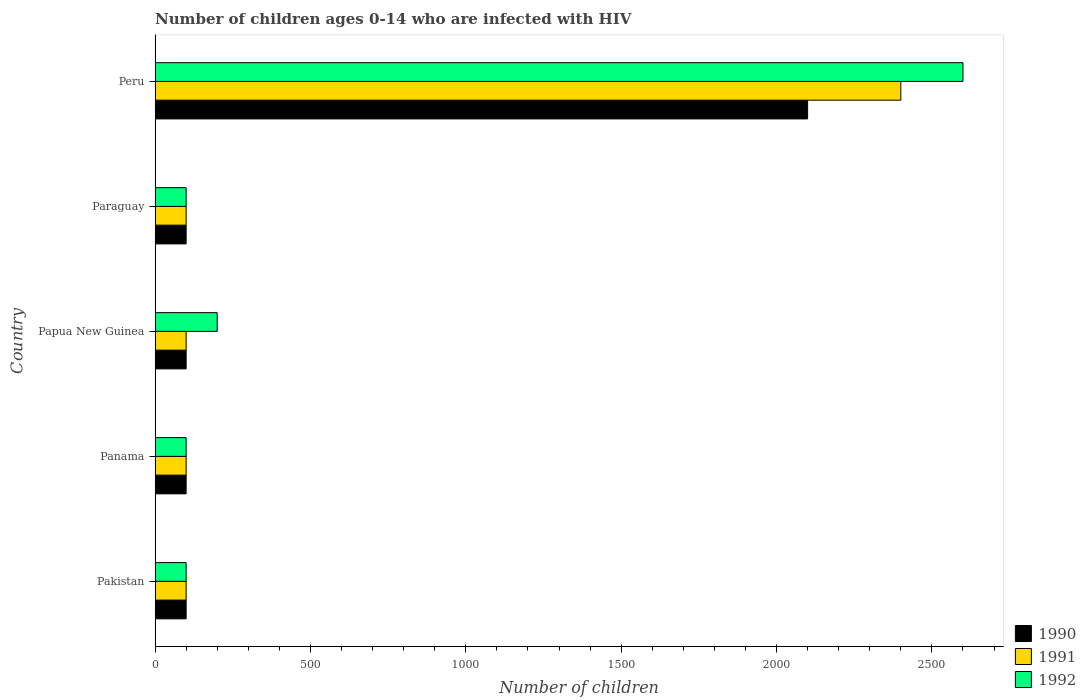How many different coloured bars are there?
Ensure brevity in your answer.  3. Are the number of bars per tick equal to the number of legend labels?
Provide a short and direct response. Yes. Are the number of bars on each tick of the Y-axis equal?
Keep it short and to the point. Yes. What is the label of the 4th group of bars from the top?
Keep it short and to the point. Panama. What is the number of HIV infected children in 1990 in Paraguay?
Keep it short and to the point. 100. Across all countries, what is the maximum number of HIV infected children in 1990?
Provide a short and direct response. 2100. Across all countries, what is the minimum number of HIV infected children in 1991?
Give a very brief answer. 100. In which country was the number of HIV infected children in 1992 minimum?
Ensure brevity in your answer.  Pakistan. What is the total number of HIV infected children in 1991 in the graph?
Your answer should be very brief. 2800. What is the difference between the number of HIV infected children in 1990 in Pakistan and that in Peru?
Provide a succinct answer. -2000. What is the difference between the number of HIV infected children in 1991 in Panama and the number of HIV infected children in 1990 in Papua New Guinea?
Provide a succinct answer. 0. What is the average number of HIV infected children in 1990 per country?
Your response must be concise. 500. What is the difference between the number of HIV infected children in 1992 and number of HIV infected children in 1990 in Papua New Guinea?
Provide a succinct answer. 100. What is the ratio of the number of HIV infected children in 1992 in Pakistan to that in Peru?
Make the answer very short. 0.04. Is the difference between the number of HIV infected children in 1992 in Paraguay and Peru greater than the difference between the number of HIV infected children in 1990 in Paraguay and Peru?
Offer a very short reply. No. What is the difference between the highest and the second highest number of HIV infected children in 1992?
Your answer should be compact. 2400. What is the difference between the highest and the lowest number of HIV infected children in 1990?
Offer a terse response. 2000. Is the sum of the number of HIV infected children in 1992 in Pakistan and Panama greater than the maximum number of HIV infected children in 1991 across all countries?
Offer a terse response. No. What does the 2nd bar from the bottom in Pakistan represents?
Your response must be concise. 1991. Does the graph contain any zero values?
Provide a succinct answer. No. Where does the legend appear in the graph?
Provide a short and direct response. Bottom right. How many legend labels are there?
Offer a terse response. 3. What is the title of the graph?
Ensure brevity in your answer.  Number of children ages 0-14 who are infected with HIV. What is the label or title of the X-axis?
Offer a very short reply. Number of children. What is the label or title of the Y-axis?
Ensure brevity in your answer.  Country. What is the Number of children in 1990 in Pakistan?
Offer a terse response. 100. What is the Number of children in 1992 in Panama?
Provide a succinct answer. 100. What is the Number of children in 1990 in Papua New Guinea?
Ensure brevity in your answer.  100. What is the Number of children in 1991 in Papua New Guinea?
Offer a very short reply. 100. What is the Number of children of 1990 in Paraguay?
Your answer should be very brief. 100. What is the Number of children of 1991 in Paraguay?
Your answer should be very brief. 100. What is the Number of children in 1990 in Peru?
Keep it short and to the point. 2100. What is the Number of children in 1991 in Peru?
Your answer should be compact. 2400. What is the Number of children of 1992 in Peru?
Give a very brief answer. 2600. Across all countries, what is the maximum Number of children of 1990?
Make the answer very short. 2100. Across all countries, what is the maximum Number of children in 1991?
Provide a short and direct response. 2400. Across all countries, what is the maximum Number of children of 1992?
Give a very brief answer. 2600. What is the total Number of children in 1990 in the graph?
Give a very brief answer. 2500. What is the total Number of children in 1991 in the graph?
Offer a terse response. 2800. What is the total Number of children of 1992 in the graph?
Provide a short and direct response. 3100. What is the difference between the Number of children of 1990 in Pakistan and that in Panama?
Your response must be concise. 0. What is the difference between the Number of children in 1991 in Pakistan and that in Panama?
Provide a short and direct response. 0. What is the difference between the Number of children of 1992 in Pakistan and that in Papua New Guinea?
Provide a succinct answer. -100. What is the difference between the Number of children of 1990 in Pakistan and that in Paraguay?
Offer a very short reply. 0. What is the difference between the Number of children in 1991 in Pakistan and that in Paraguay?
Provide a succinct answer. 0. What is the difference between the Number of children in 1990 in Pakistan and that in Peru?
Make the answer very short. -2000. What is the difference between the Number of children in 1991 in Pakistan and that in Peru?
Your answer should be very brief. -2300. What is the difference between the Number of children in 1992 in Pakistan and that in Peru?
Keep it short and to the point. -2500. What is the difference between the Number of children of 1990 in Panama and that in Papua New Guinea?
Your response must be concise. 0. What is the difference between the Number of children of 1992 in Panama and that in Papua New Guinea?
Provide a short and direct response. -100. What is the difference between the Number of children of 1990 in Panama and that in Paraguay?
Keep it short and to the point. 0. What is the difference between the Number of children in 1991 in Panama and that in Paraguay?
Provide a short and direct response. 0. What is the difference between the Number of children of 1990 in Panama and that in Peru?
Ensure brevity in your answer.  -2000. What is the difference between the Number of children of 1991 in Panama and that in Peru?
Keep it short and to the point. -2300. What is the difference between the Number of children of 1992 in Panama and that in Peru?
Provide a succinct answer. -2500. What is the difference between the Number of children in 1990 in Papua New Guinea and that in Paraguay?
Offer a terse response. 0. What is the difference between the Number of children in 1991 in Papua New Guinea and that in Paraguay?
Give a very brief answer. 0. What is the difference between the Number of children of 1990 in Papua New Guinea and that in Peru?
Your response must be concise. -2000. What is the difference between the Number of children in 1991 in Papua New Guinea and that in Peru?
Your response must be concise. -2300. What is the difference between the Number of children of 1992 in Papua New Guinea and that in Peru?
Offer a very short reply. -2400. What is the difference between the Number of children of 1990 in Paraguay and that in Peru?
Your response must be concise. -2000. What is the difference between the Number of children of 1991 in Paraguay and that in Peru?
Make the answer very short. -2300. What is the difference between the Number of children of 1992 in Paraguay and that in Peru?
Ensure brevity in your answer.  -2500. What is the difference between the Number of children of 1991 in Pakistan and the Number of children of 1992 in Panama?
Provide a succinct answer. 0. What is the difference between the Number of children in 1990 in Pakistan and the Number of children in 1992 in Papua New Guinea?
Ensure brevity in your answer.  -100. What is the difference between the Number of children in 1991 in Pakistan and the Number of children in 1992 in Papua New Guinea?
Offer a very short reply. -100. What is the difference between the Number of children of 1990 in Pakistan and the Number of children of 1991 in Paraguay?
Your answer should be very brief. 0. What is the difference between the Number of children of 1991 in Pakistan and the Number of children of 1992 in Paraguay?
Your answer should be very brief. 0. What is the difference between the Number of children of 1990 in Pakistan and the Number of children of 1991 in Peru?
Your response must be concise. -2300. What is the difference between the Number of children of 1990 in Pakistan and the Number of children of 1992 in Peru?
Your answer should be very brief. -2500. What is the difference between the Number of children of 1991 in Pakistan and the Number of children of 1992 in Peru?
Offer a very short reply. -2500. What is the difference between the Number of children of 1990 in Panama and the Number of children of 1992 in Papua New Guinea?
Provide a short and direct response. -100. What is the difference between the Number of children of 1991 in Panama and the Number of children of 1992 in Papua New Guinea?
Keep it short and to the point. -100. What is the difference between the Number of children of 1990 in Panama and the Number of children of 1991 in Paraguay?
Your answer should be very brief. 0. What is the difference between the Number of children of 1991 in Panama and the Number of children of 1992 in Paraguay?
Offer a very short reply. 0. What is the difference between the Number of children in 1990 in Panama and the Number of children in 1991 in Peru?
Give a very brief answer. -2300. What is the difference between the Number of children in 1990 in Panama and the Number of children in 1992 in Peru?
Provide a succinct answer. -2500. What is the difference between the Number of children in 1991 in Panama and the Number of children in 1992 in Peru?
Provide a succinct answer. -2500. What is the difference between the Number of children in 1990 in Papua New Guinea and the Number of children in 1991 in Paraguay?
Keep it short and to the point. 0. What is the difference between the Number of children of 1991 in Papua New Guinea and the Number of children of 1992 in Paraguay?
Your answer should be very brief. 0. What is the difference between the Number of children in 1990 in Papua New Guinea and the Number of children in 1991 in Peru?
Keep it short and to the point. -2300. What is the difference between the Number of children of 1990 in Papua New Guinea and the Number of children of 1992 in Peru?
Give a very brief answer. -2500. What is the difference between the Number of children of 1991 in Papua New Guinea and the Number of children of 1992 in Peru?
Make the answer very short. -2500. What is the difference between the Number of children in 1990 in Paraguay and the Number of children in 1991 in Peru?
Keep it short and to the point. -2300. What is the difference between the Number of children of 1990 in Paraguay and the Number of children of 1992 in Peru?
Offer a very short reply. -2500. What is the difference between the Number of children in 1991 in Paraguay and the Number of children in 1992 in Peru?
Give a very brief answer. -2500. What is the average Number of children of 1990 per country?
Your answer should be very brief. 500. What is the average Number of children of 1991 per country?
Provide a short and direct response. 560. What is the average Number of children of 1992 per country?
Give a very brief answer. 620. What is the difference between the Number of children in 1990 and Number of children in 1991 in Pakistan?
Your response must be concise. 0. What is the difference between the Number of children of 1990 and Number of children of 1992 in Pakistan?
Provide a short and direct response. 0. What is the difference between the Number of children in 1991 and Number of children in 1992 in Pakistan?
Make the answer very short. 0. What is the difference between the Number of children of 1991 and Number of children of 1992 in Panama?
Give a very brief answer. 0. What is the difference between the Number of children of 1990 and Number of children of 1991 in Papua New Guinea?
Keep it short and to the point. 0. What is the difference between the Number of children of 1990 and Number of children of 1992 in Papua New Guinea?
Keep it short and to the point. -100. What is the difference between the Number of children of 1991 and Number of children of 1992 in Papua New Guinea?
Your answer should be compact. -100. What is the difference between the Number of children of 1990 and Number of children of 1991 in Paraguay?
Offer a terse response. 0. What is the difference between the Number of children in 1990 and Number of children in 1991 in Peru?
Offer a very short reply. -300. What is the difference between the Number of children of 1990 and Number of children of 1992 in Peru?
Provide a short and direct response. -500. What is the difference between the Number of children of 1991 and Number of children of 1992 in Peru?
Your response must be concise. -200. What is the ratio of the Number of children in 1990 in Pakistan to that in Panama?
Keep it short and to the point. 1. What is the ratio of the Number of children of 1990 in Pakistan to that in Paraguay?
Keep it short and to the point. 1. What is the ratio of the Number of children of 1992 in Pakistan to that in Paraguay?
Keep it short and to the point. 1. What is the ratio of the Number of children of 1990 in Pakistan to that in Peru?
Your answer should be compact. 0.05. What is the ratio of the Number of children of 1991 in Pakistan to that in Peru?
Provide a succinct answer. 0.04. What is the ratio of the Number of children in 1992 in Pakistan to that in Peru?
Make the answer very short. 0.04. What is the ratio of the Number of children of 1990 in Panama to that in Papua New Guinea?
Offer a very short reply. 1. What is the ratio of the Number of children of 1992 in Panama to that in Papua New Guinea?
Offer a terse response. 0.5. What is the ratio of the Number of children in 1990 in Panama to that in Peru?
Your answer should be very brief. 0.05. What is the ratio of the Number of children in 1991 in Panama to that in Peru?
Offer a very short reply. 0.04. What is the ratio of the Number of children in 1992 in Panama to that in Peru?
Provide a short and direct response. 0.04. What is the ratio of the Number of children of 1991 in Papua New Guinea to that in Paraguay?
Your response must be concise. 1. What is the ratio of the Number of children of 1990 in Papua New Guinea to that in Peru?
Keep it short and to the point. 0.05. What is the ratio of the Number of children in 1991 in Papua New Guinea to that in Peru?
Ensure brevity in your answer.  0.04. What is the ratio of the Number of children of 1992 in Papua New Guinea to that in Peru?
Your answer should be very brief. 0.08. What is the ratio of the Number of children of 1990 in Paraguay to that in Peru?
Provide a succinct answer. 0.05. What is the ratio of the Number of children in 1991 in Paraguay to that in Peru?
Your answer should be compact. 0.04. What is the ratio of the Number of children of 1992 in Paraguay to that in Peru?
Give a very brief answer. 0.04. What is the difference between the highest and the second highest Number of children of 1990?
Give a very brief answer. 2000. What is the difference between the highest and the second highest Number of children in 1991?
Provide a short and direct response. 2300. What is the difference between the highest and the second highest Number of children in 1992?
Keep it short and to the point. 2400. What is the difference between the highest and the lowest Number of children in 1990?
Your answer should be compact. 2000. What is the difference between the highest and the lowest Number of children of 1991?
Keep it short and to the point. 2300. What is the difference between the highest and the lowest Number of children in 1992?
Give a very brief answer. 2500. 